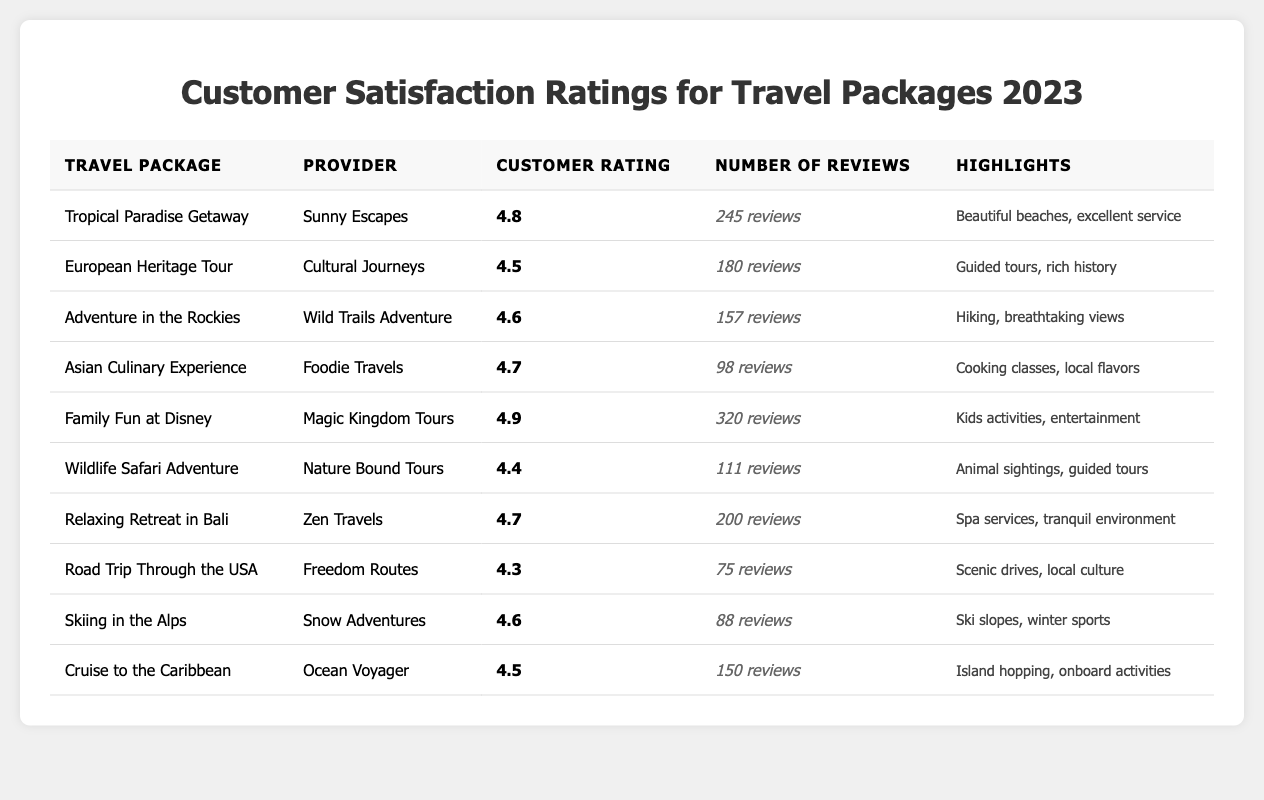What is the highest customer rating among the travel packages? The table shows that the "Family Fun at Disney" package has the highest customer rating of 4.9.
Answer: 4.9 How many reviews did the "Asian Culinary Experience" package receive? The table lists that the "Asian Culinary Experience" package received 98 reviews.
Answer: 98 Which travel package has the lowest customer rating? By examining the customer ratings, the "Wildlife Safari Adventure" has the lowest customer rating of 4.4.
Answer: 4.4 What is the average customer rating of all travel packages? To find the average, sum all the customer ratings (4.8 + 4.5 + 4.6 + 4.7 + 4.9 + 4.4 + 4.7 + 4.3 + 4.6 + 4.5 = 46.6). There are 10 packages, so the average is 46.6 / 10 = 4.66.
Answer: 4.66 Which travel package has the highest number of reviews? The "Family Fun at Disney" package has the highest number of reviews, with 320 reviews.
Answer: 320 Is the "Relaxing Retreat in Bali" package rated higher than 4.5? The customer rating for "Relaxing Retreat in Bali" is 4.7, which is higher than 4.5.
Answer: Yes How many packages have a customer rating greater than 4.6? The packages with customer ratings greater than 4.6 are "Tropical Paradise Getaway" (4.8), "Family Fun at Disney" (4.9), "Asian Culinary Experience" (4.7), and "Relaxing Retreat in Bali" (4.7). This totals to 4 packages.
Answer: 4 What are the highlights of the "Cruise to the Caribbean" package? The highlights for "Cruise to the Caribbean" include "Island hopping" and "onboard activities."
Answer: Island hopping, onboard activities Calculate the total number of reviews for all travel packages combined. The total reviews can be calculated by summing the individual reviews (245 + 180 + 157 + 98 + 320 + 111 + 200 + 75 + 88 + 150 = 1374).
Answer: 1374 Do any travel packages have customer ratings at or above 4.7? Yes, the "Tropical Paradise Getaway" (4.8), "Family Fun at Disney" (4.9), "Asian Culinary Experience" (4.7), and "Relaxing Retreat in Bali" (4.7) all have ratings at or above 4.7.
Answer: Yes 